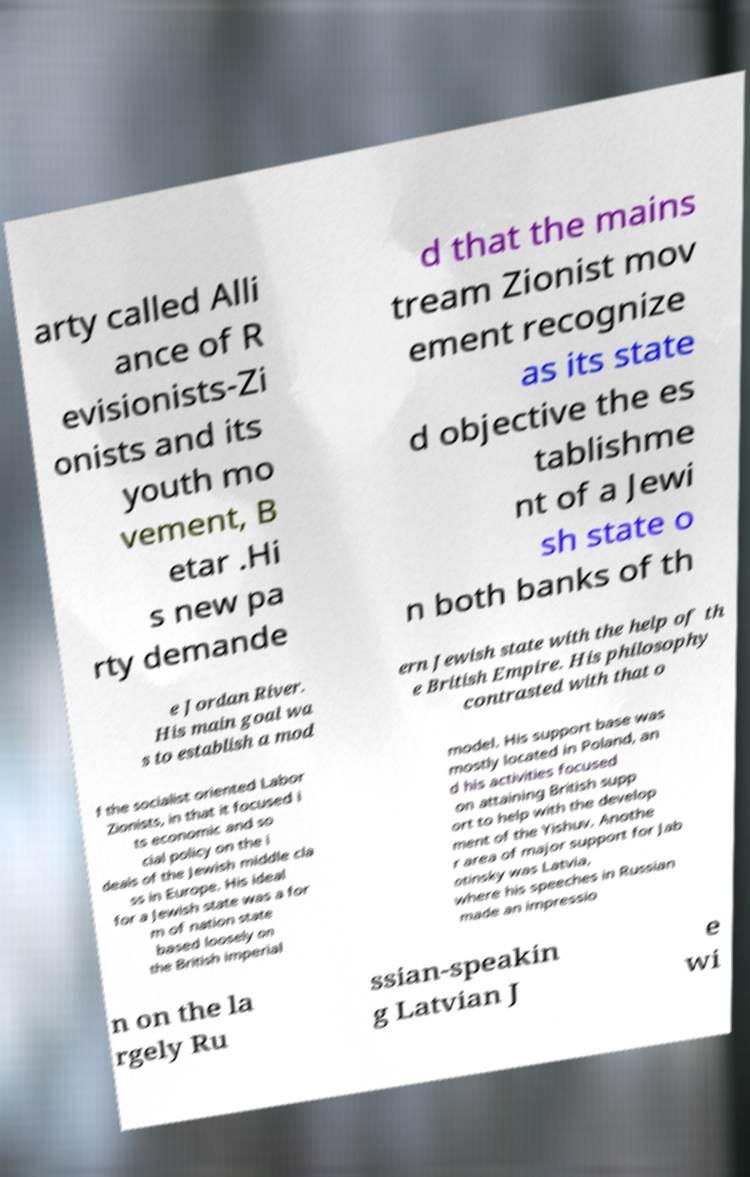I need the written content from this picture converted into text. Can you do that? arty called Alli ance of R evisionists-Zi onists and its youth mo vement, B etar .Hi s new pa rty demande d that the mains tream Zionist mov ement recognize as its state d objective the es tablishme nt of a Jewi sh state o n both banks of th e Jordan River. His main goal wa s to establish a mod ern Jewish state with the help of th e British Empire. His philosophy contrasted with that o f the socialist oriented Labor Zionists, in that it focused i ts economic and so cial policy on the i deals of the Jewish middle cla ss in Europe. His ideal for a Jewish state was a for m of nation state based loosely on the British imperial model. His support base was mostly located in Poland, an d his activities focused on attaining British supp ort to help with the develop ment of the Yishuv. Anothe r area of major support for Jab otinsky was Latvia, where his speeches in Russian made an impressio n on the la rgely Ru ssian-speakin g Latvian J e wi 